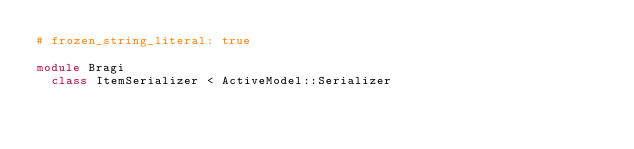Convert code to text. <code><loc_0><loc_0><loc_500><loc_500><_Ruby_># frozen_string_literal: true

module Bragi
  class ItemSerializer < ActiveModel::Serializer</code> 